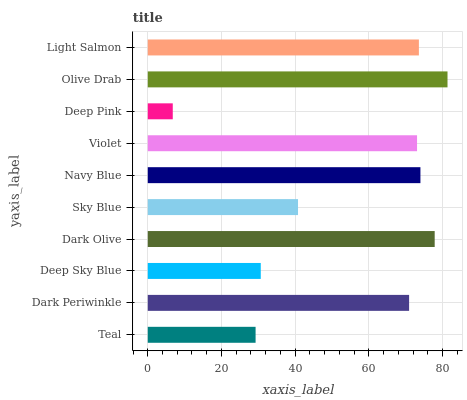Is Deep Pink the minimum?
Answer yes or no. Yes. Is Olive Drab the maximum?
Answer yes or no. Yes. Is Dark Periwinkle the minimum?
Answer yes or no. No. Is Dark Periwinkle the maximum?
Answer yes or no. No. Is Dark Periwinkle greater than Teal?
Answer yes or no. Yes. Is Teal less than Dark Periwinkle?
Answer yes or no. Yes. Is Teal greater than Dark Periwinkle?
Answer yes or no. No. Is Dark Periwinkle less than Teal?
Answer yes or no. No. Is Violet the high median?
Answer yes or no. Yes. Is Dark Periwinkle the low median?
Answer yes or no. Yes. Is Sky Blue the high median?
Answer yes or no. No. Is Sky Blue the low median?
Answer yes or no. No. 